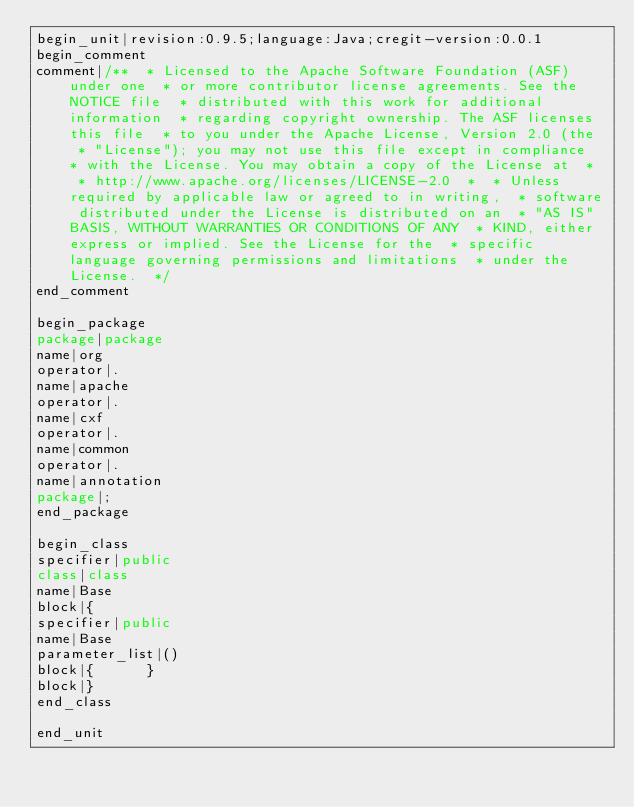<code> <loc_0><loc_0><loc_500><loc_500><_Java_>begin_unit|revision:0.9.5;language:Java;cregit-version:0.0.1
begin_comment
comment|/**  * Licensed to the Apache Software Foundation (ASF) under one  * or more contributor license agreements. See the NOTICE file  * distributed with this work for additional information  * regarding copyright ownership. The ASF licenses this file  * to you under the Apache License, Version 2.0 (the  * "License"); you may not use this file except in compliance  * with the License. You may obtain a copy of the License at  *  * http://www.apache.org/licenses/LICENSE-2.0  *  * Unless required by applicable law or agreed to in writing,  * software distributed under the License is distributed on an  * "AS IS" BASIS, WITHOUT WARRANTIES OR CONDITIONS OF ANY  * KIND, either express or implied. See the License for the  * specific language governing permissions and limitations  * under the License.  */
end_comment

begin_package
package|package
name|org
operator|.
name|apache
operator|.
name|cxf
operator|.
name|common
operator|.
name|annotation
package|;
end_package

begin_class
specifier|public
class|class
name|Base
block|{
specifier|public
name|Base
parameter_list|()
block|{      }
block|}
end_class

end_unit

</code> 